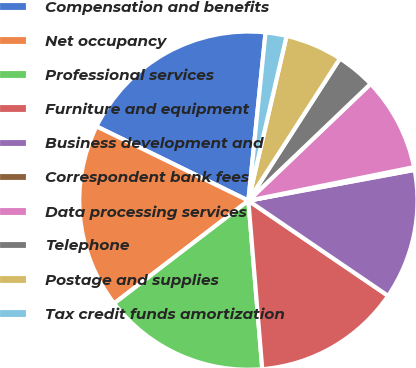Convert chart. <chart><loc_0><loc_0><loc_500><loc_500><pie_chart><fcel>Compensation and benefits<fcel>Net occupancy<fcel>Professional services<fcel>Furniture and equipment<fcel>Business development and<fcel>Correspondent bank fees<fcel>Data processing services<fcel>Telephone<fcel>Postage and supplies<fcel>Tax credit funds amortization<nl><fcel>19.38%<fcel>17.64%<fcel>15.91%<fcel>14.17%<fcel>12.43%<fcel>0.27%<fcel>8.96%<fcel>3.75%<fcel>5.48%<fcel>2.01%<nl></chart> 